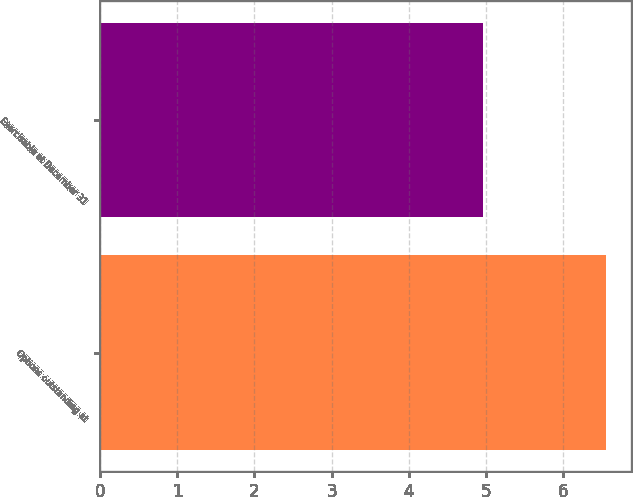Convert chart to OTSL. <chart><loc_0><loc_0><loc_500><loc_500><bar_chart><fcel>Options outstanding at<fcel>Exercisable at December 31<nl><fcel>6.55<fcel>4.96<nl></chart> 